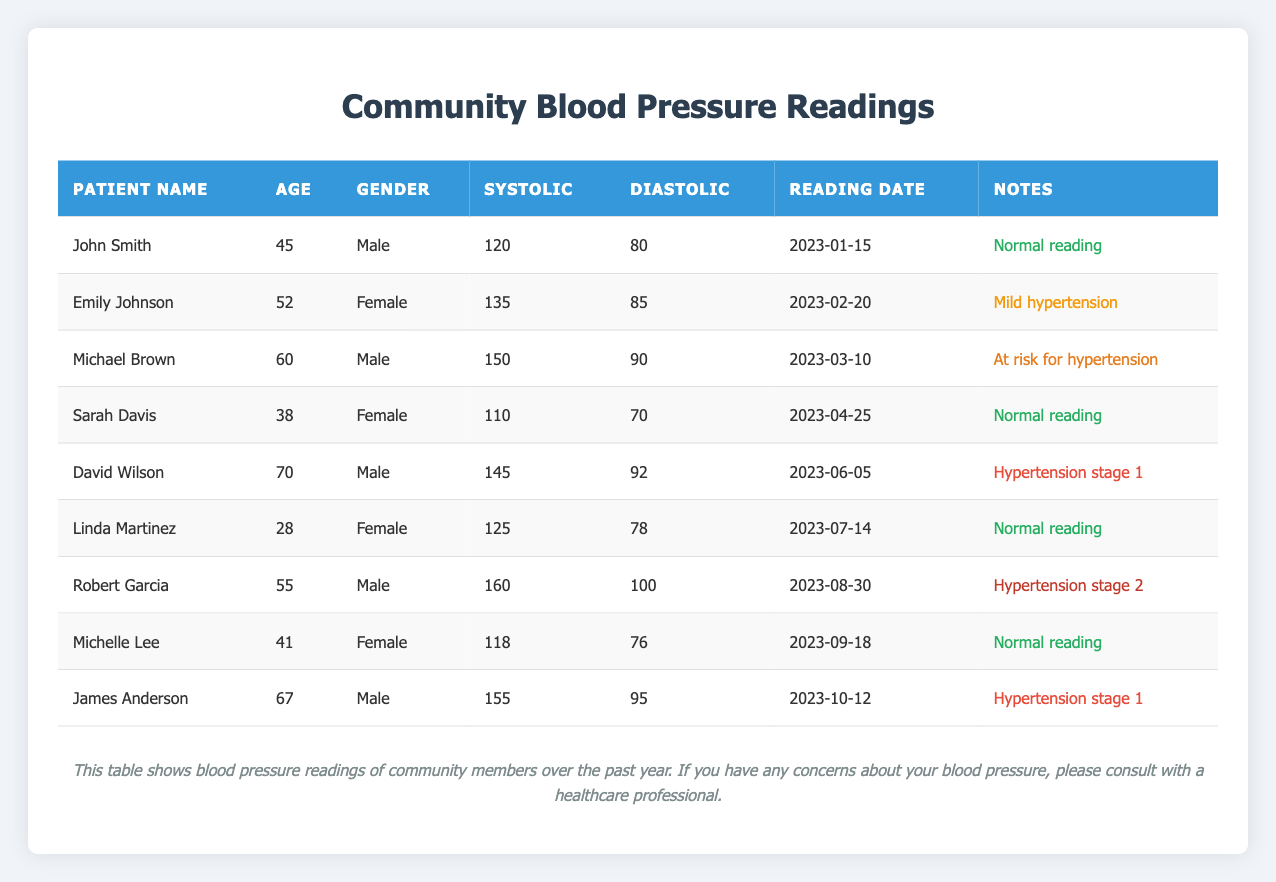What is the systolic reading of Robert Garcia? Robert Garcia's systolic reading is found in his row under the 'Systolic' column where his details are listed. The table shows that his systolic reading is 160.
Answer: 160 How many patients have normal blood pressure readings? To answer this, we can look for entries in the 'Notes' column that indicate a "Normal reading." The patients with normal readings are John Smith, Sarah Davis, Linda Martinez, and Michelle Lee, giving a total count of 4.
Answer: 4 What is the average diastolic pressure of the patients listed? To find the average, we sum up the diastolic readings and divide by the number of entries. The diastolic readings are 80, 85, 90, 70, 92, 78, 100, 76, and 95. The sum of these values is 80 + 85 + 90 + 70 + 92 + 78 + 100 + 76 + 95 = 796. There are 9 readings, so the average is 796 / 9 = 88.44.
Answer: 88.44 Is Emily Johnson's diastolic reading higher than David Wilson's? Emily Johnson's diastolic reading is 85, while David Wilson's is 92. Since 85 is less than 92, the answer is no.
Answer: No Which patient had a blood pressure reading classified as "Hypertension stage 2"? By scanning the 'Notes' column for the classification "Hypertension stage 2," we find that Robert Garcia is the patient with this classification, noted in his row.
Answer: Robert Garcia What is the total systolic reading of all patients considered at risk for hypertension? Patients classified as at risk for hypertension include Michael Brown and James Anderson, with systolic readings of 150 and 155, respectively. Adding these readings gives a total of 150 + 155 = 305.
Answer: 305 Is the average systolic reading greater than 140? To determine this, we first calculate the average systolic reading for all patients. The systolic values are 120, 135, 150, 110, 145, 125, 160, 118, and 155. The total sum is 120 + 135 + 150 + 110 + 145 + 125 + 160 + 118 + 155 = 1,175. There are 9 values, so the average is 1,175 / 9 ≈ 130.56, which is less than 140.
Answer: No Who is the male patient with the highest diastolic pressure? By comparing the diastolic readings of male patients, we have 80, 90, 92, 100, and 95 for John Smith, Michael Brown, David Wilson, Robert Garcia, and James Anderson, respectively. The highest diastolic reading is 100 for Robert Garcia.
Answer: Robert Garcia How many patients are considered to have hypertension stage 1? Scanning the 'Notes' column for "Hypertension stage 1," we find that both David Wilson and James Anderson fall into this category, resulting in a total of 2 patients.
Answer: 2 